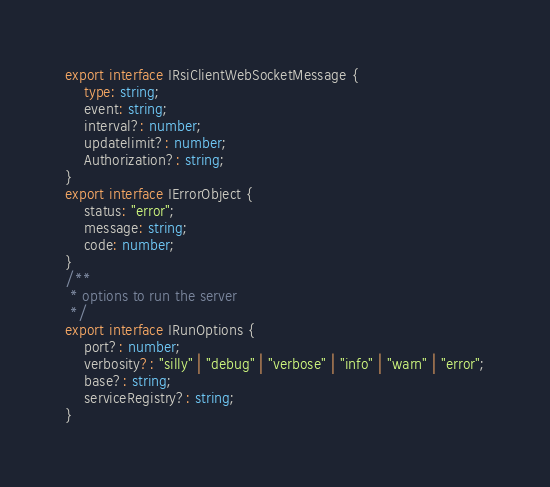Convert code to text. <code><loc_0><loc_0><loc_500><loc_500><_TypeScript_>export interface IRsiClientWebSocketMessage {
    type: string;
    event: string;
    interval?: number;
    updatelimit?: number;
    Authorization?: string;
}
export interface IErrorObject {
    status: "error";
    message: string;
    code: number;
}
/**
 * options to run the server
 */
export interface IRunOptions {
    port?: number;
    verbosity?: "silly" | "debug" | "verbose" | "info" | "warn" | "error";
    base?: string;
    serviceRegistry?: string;
}
</code> 